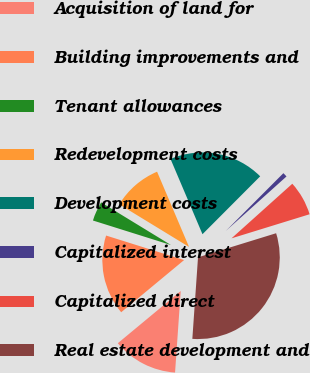<chart> <loc_0><loc_0><loc_500><loc_500><pie_chart><fcel>Acquisition of land for<fcel>Building improvements and<fcel>Tenant allowances<fcel>Redevelopment costs<fcel>Development costs<fcel>Capitalized interest<fcel>Capitalized direct<fcel>Real estate development and<nl><fcel>12.87%<fcel>15.87%<fcel>3.88%<fcel>9.88%<fcel>18.87%<fcel>0.88%<fcel>6.88%<fcel>30.87%<nl></chart> 